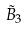<formula> <loc_0><loc_0><loc_500><loc_500>\tilde { B } _ { 3 }</formula> 